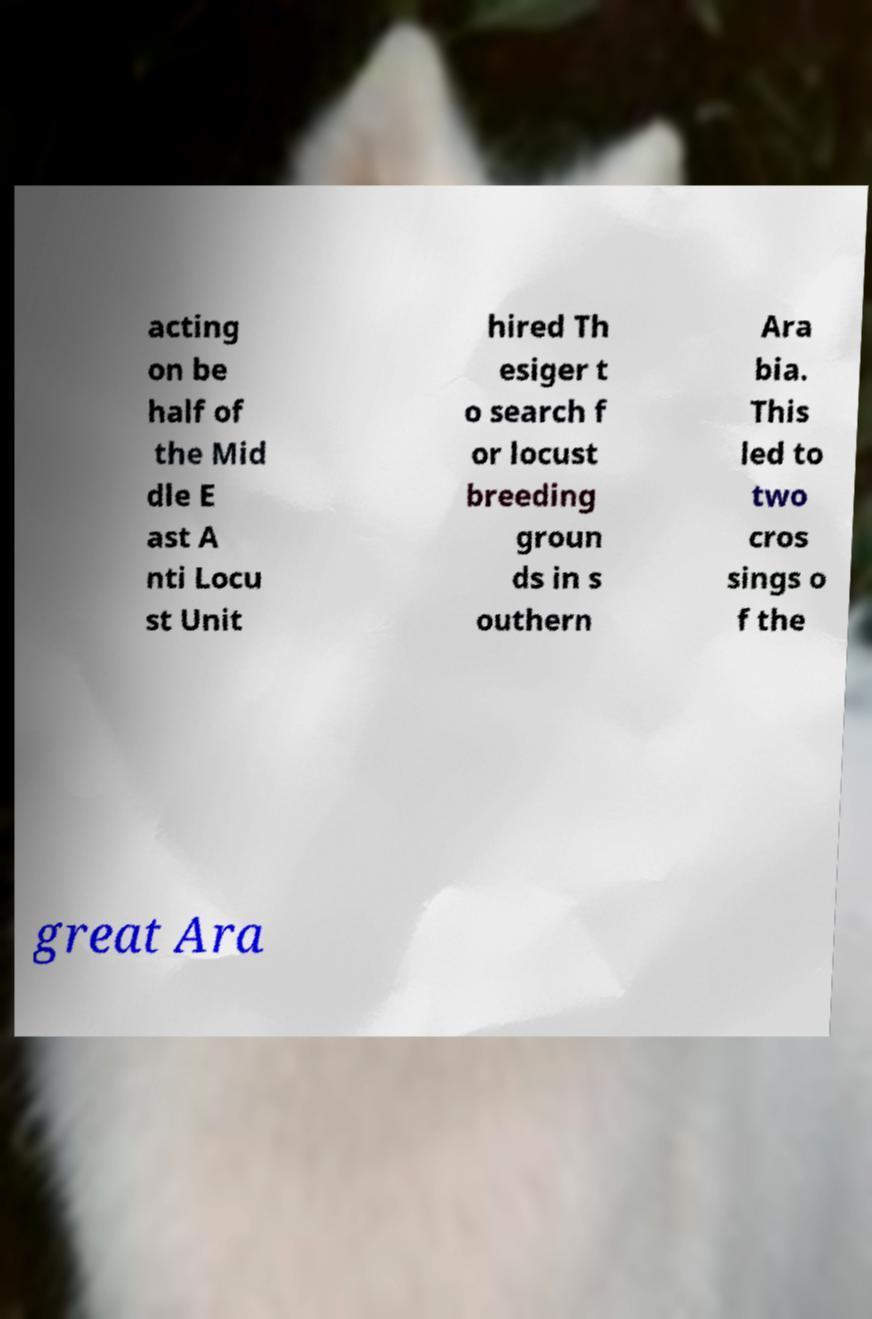For documentation purposes, I need the text within this image transcribed. Could you provide that? acting on be half of the Mid dle E ast A nti Locu st Unit hired Th esiger t o search f or locust breeding groun ds in s outhern Ara bia. This led to two cros sings o f the great Ara 